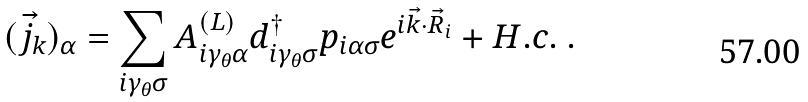Convert formula to latex. <formula><loc_0><loc_0><loc_500><loc_500>( \vec { j } _ { k } ) _ { \alpha } = \sum _ { i \gamma _ { \theta } \sigma } A ^ { ( L ) } _ { i \gamma _ { \theta } \alpha } d _ { i \gamma _ { \theta } \sigma } ^ { \dagger } p _ { i \alpha \sigma } e ^ { i \vec { k } \cdot \vec { R } _ { i } } + H . c . \ .</formula> 